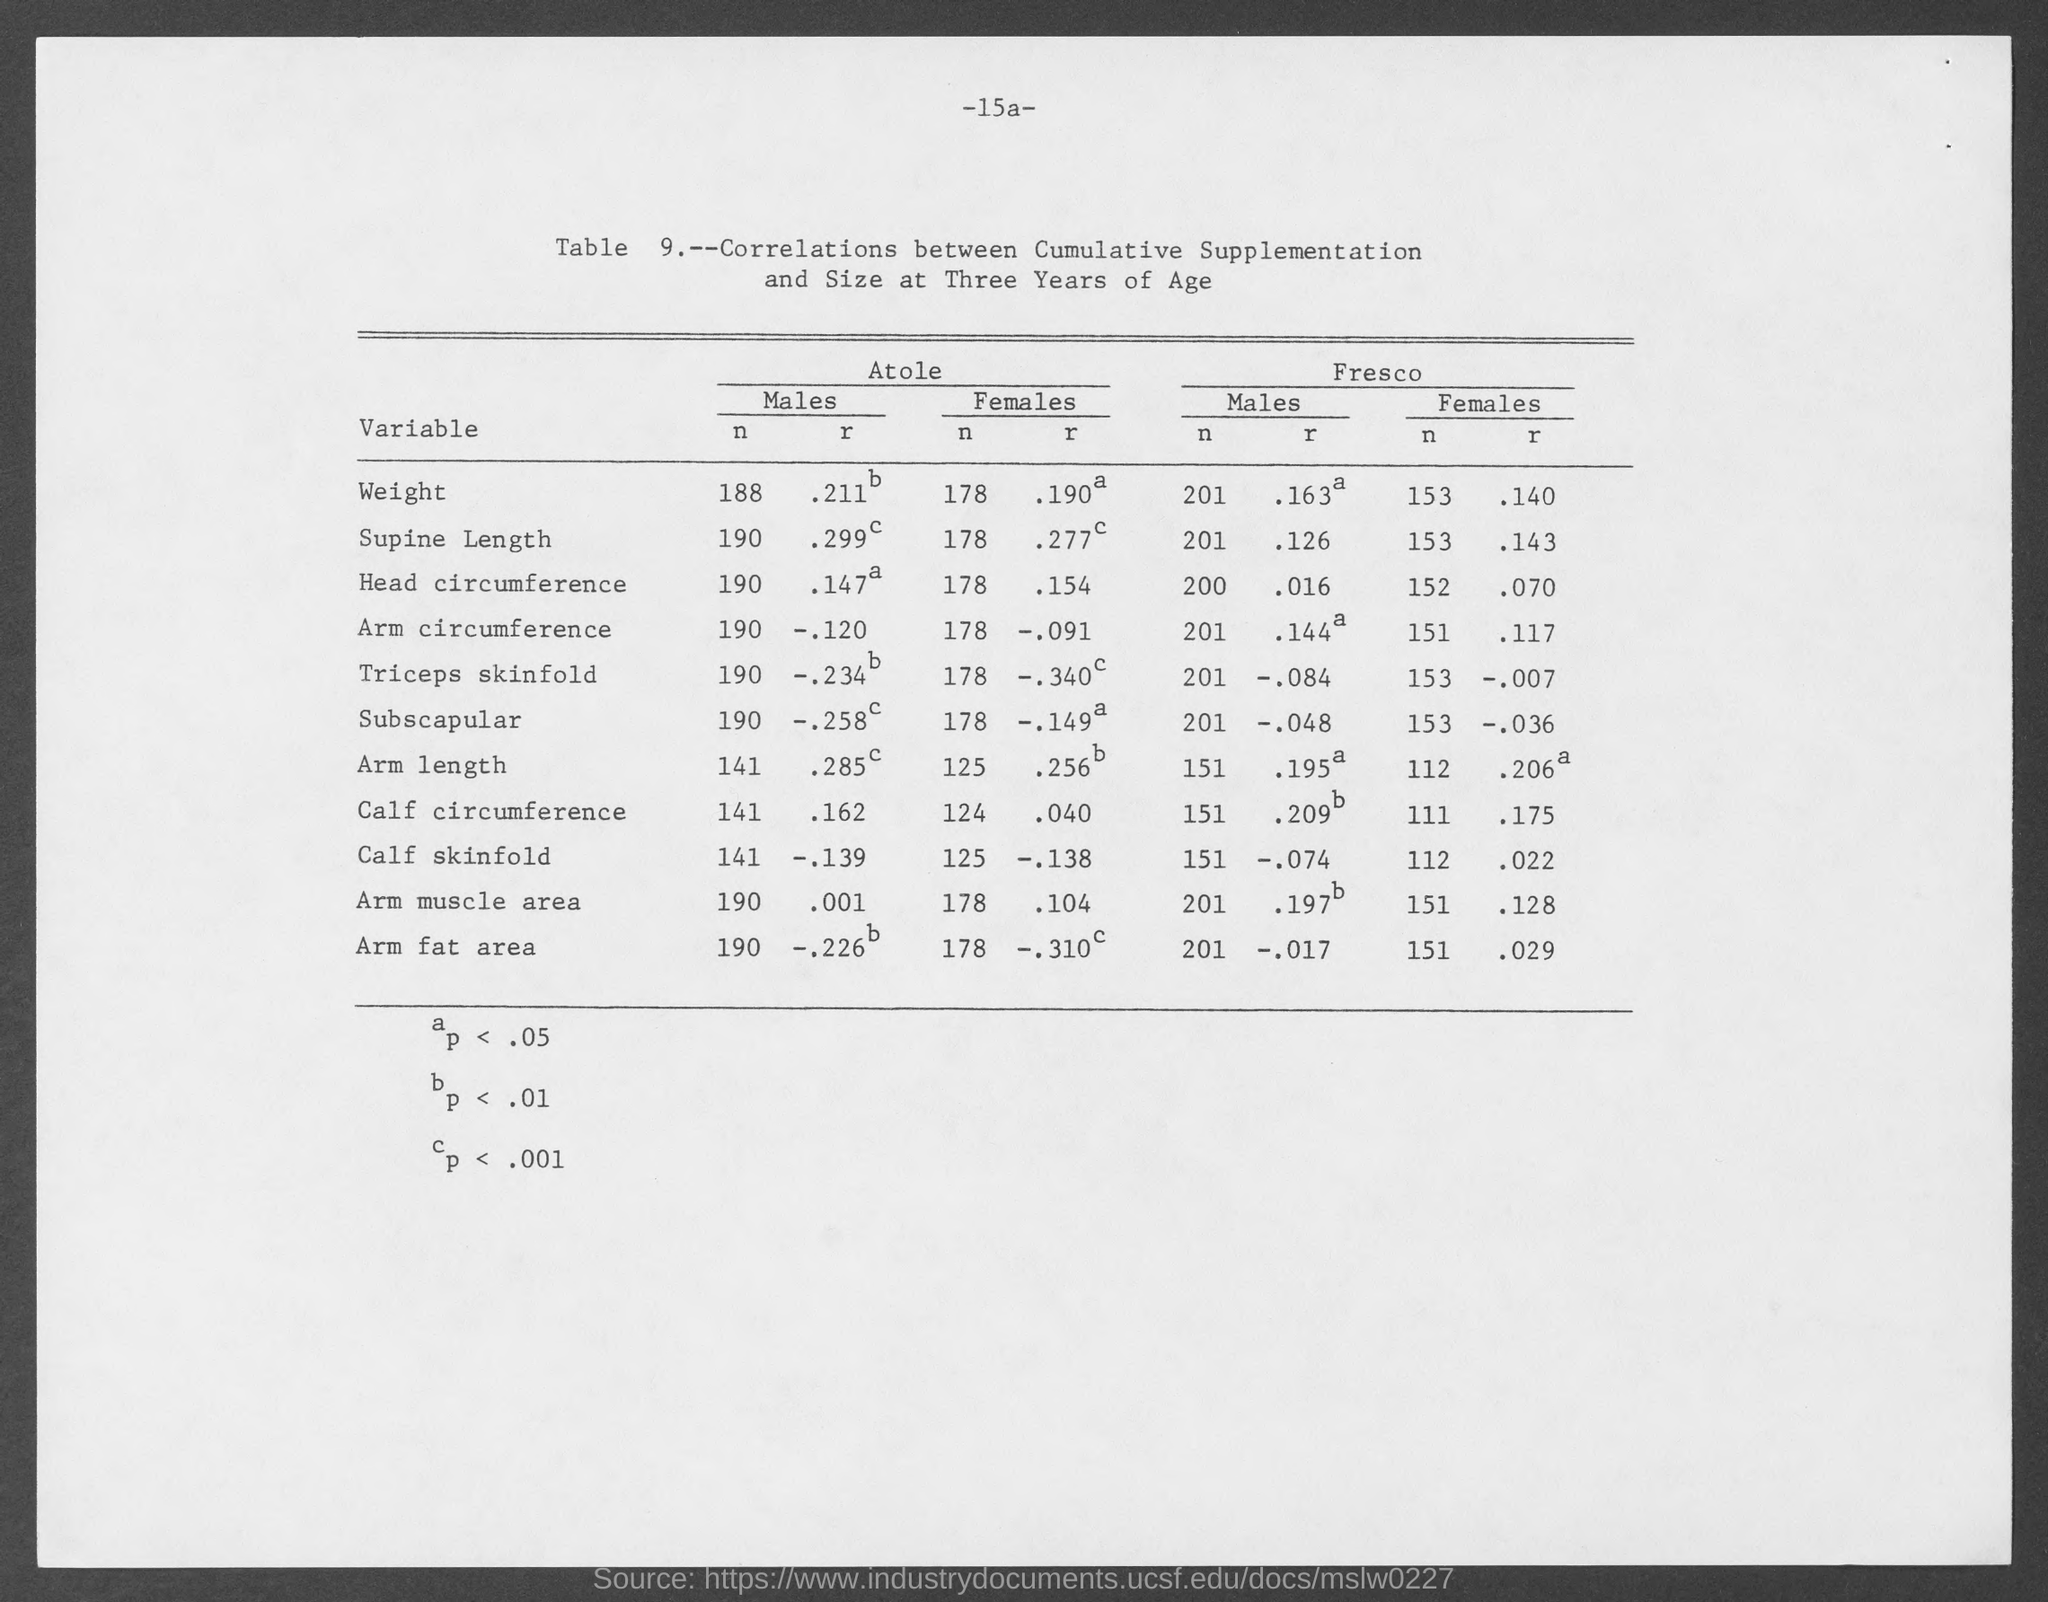What is the page number?
Keep it short and to the point. 15a. What is the table number?
Your answer should be compact. 9. 